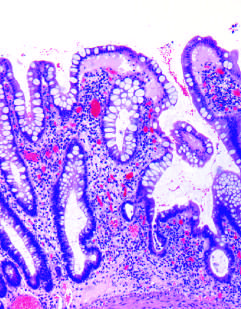what results from repeated injury and regeneration?
Answer the question using a single word or phrase. Haphazard crypt organization 